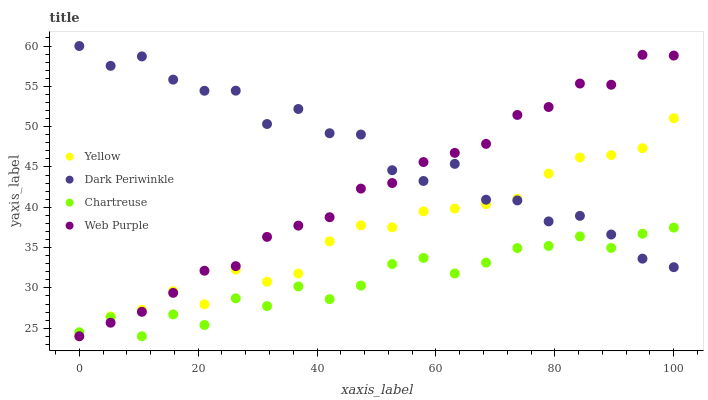Does Chartreuse have the minimum area under the curve?
Answer yes or no. Yes. Does Dark Periwinkle have the maximum area under the curve?
Answer yes or no. Yes. Does Dark Periwinkle have the minimum area under the curve?
Answer yes or no. No. Does Chartreuse have the maximum area under the curve?
Answer yes or no. No. Is Web Purple the smoothest?
Answer yes or no. Yes. Is Dark Periwinkle the roughest?
Answer yes or no. Yes. Is Chartreuse the smoothest?
Answer yes or no. No. Is Chartreuse the roughest?
Answer yes or no. No. Does Web Purple have the lowest value?
Answer yes or no. Yes. Does Dark Periwinkle have the lowest value?
Answer yes or no. No. Does Dark Periwinkle have the highest value?
Answer yes or no. Yes. Does Chartreuse have the highest value?
Answer yes or no. No. Does Web Purple intersect Dark Periwinkle?
Answer yes or no. Yes. Is Web Purple less than Dark Periwinkle?
Answer yes or no. No. Is Web Purple greater than Dark Periwinkle?
Answer yes or no. No. 